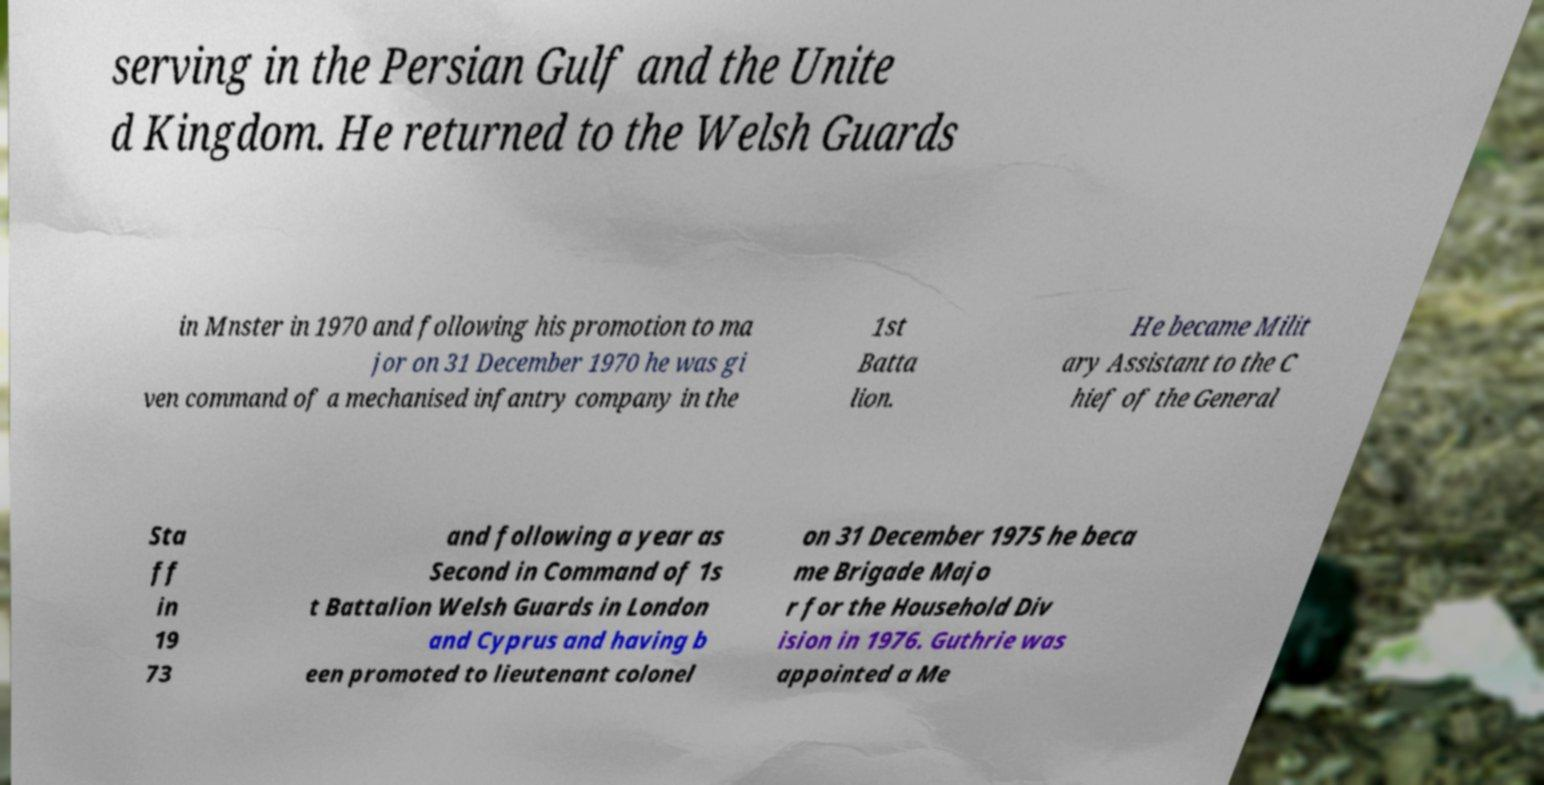There's text embedded in this image that I need extracted. Can you transcribe it verbatim? serving in the Persian Gulf and the Unite d Kingdom. He returned to the Welsh Guards in Mnster in 1970 and following his promotion to ma jor on 31 December 1970 he was gi ven command of a mechanised infantry company in the 1st Batta lion. He became Milit ary Assistant to the C hief of the General Sta ff in 19 73 and following a year as Second in Command of 1s t Battalion Welsh Guards in London and Cyprus and having b een promoted to lieutenant colonel on 31 December 1975 he beca me Brigade Majo r for the Household Div ision in 1976. Guthrie was appointed a Me 